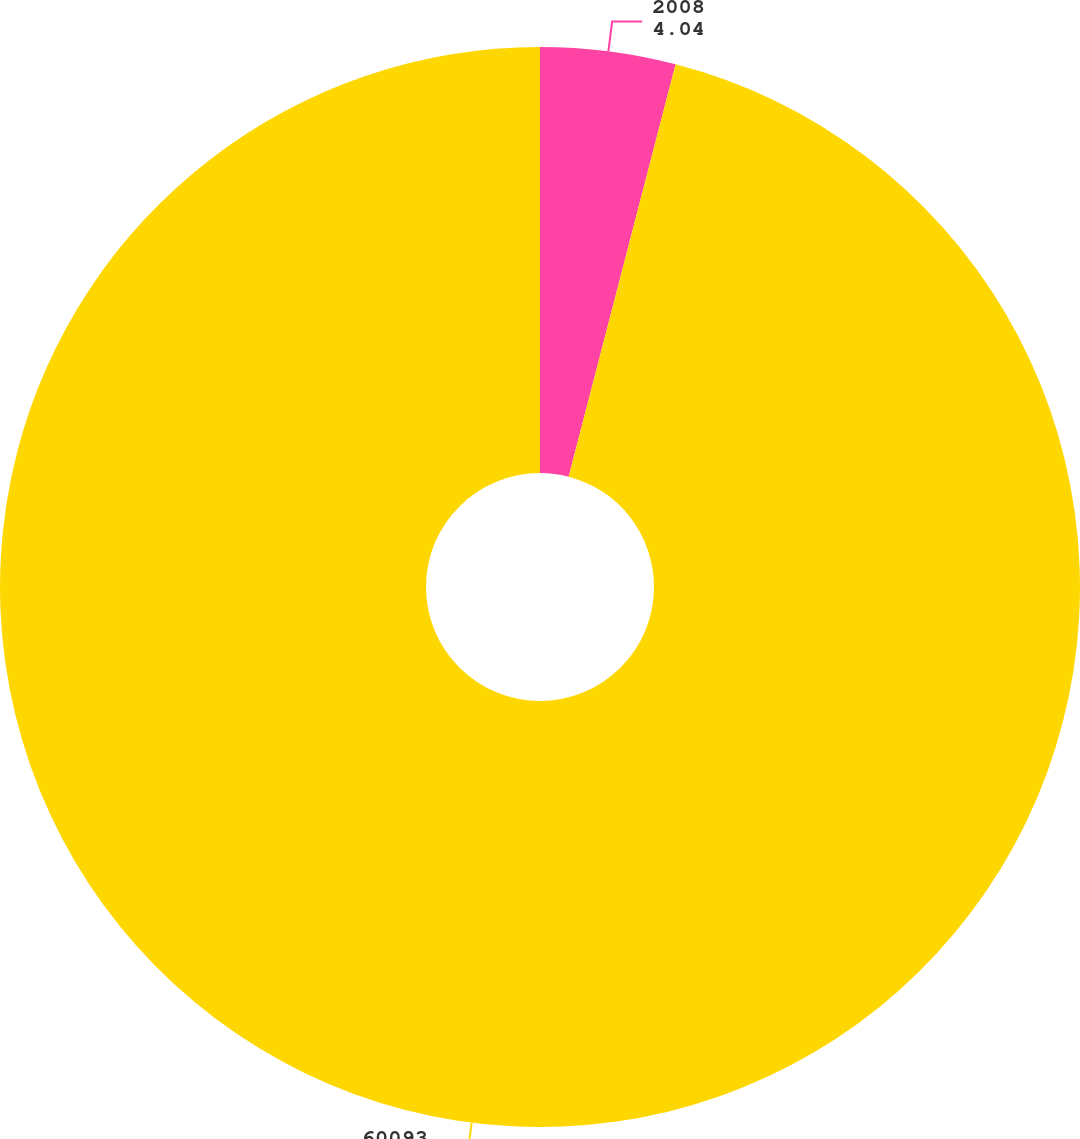Convert chart to OTSL. <chart><loc_0><loc_0><loc_500><loc_500><pie_chart><fcel>2008<fcel>60093<nl><fcel>4.04%<fcel>95.96%<nl></chart> 